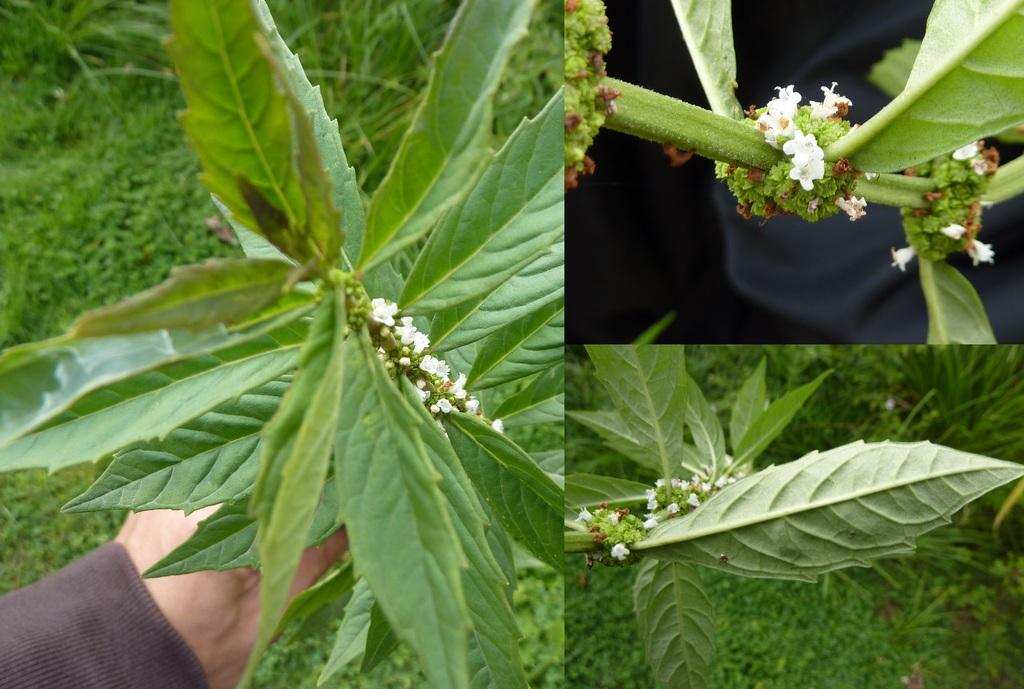How many images are combined in the collage? The image is a collage of three images. What is depicted in one of the images? There is a ground with grass in one of the images. What is shown in another image? There is a plant with leaves, stems, and flowers in one of the images. Are there any people in the collage? Yes, there is a person in one of the images. What type of tin can be seen in the image? There is no tin present in the image. What role does the governor play in the image? There is no governor depicted in the image. 